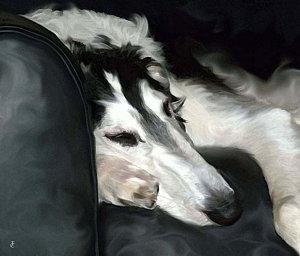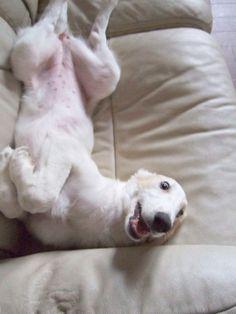The first image is the image on the left, the second image is the image on the right. Given the left and right images, does the statement "Each image shows a hound lounging on upholstered furniture, and one image shows a hound upside-down with hind legs above his front paws." hold true? Answer yes or no. Yes. The first image is the image on the left, the second image is the image on the right. For the images displayed, is the sentence "At least one dog is laying on his back." factually correct? Answer yes or no. Yes. 